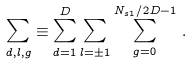Convert formula to latex. <formula><loc_0><loc_0><loc_500><loc_500>\sum _ { d , l , g } \equiv \sum _ { d = 1 } ^ { D } \sum _ { l = \pm 1 } \sum _ { g = 0 } ^ { N _ { s 1 } / 2 D - 1 } \, .</formula> 